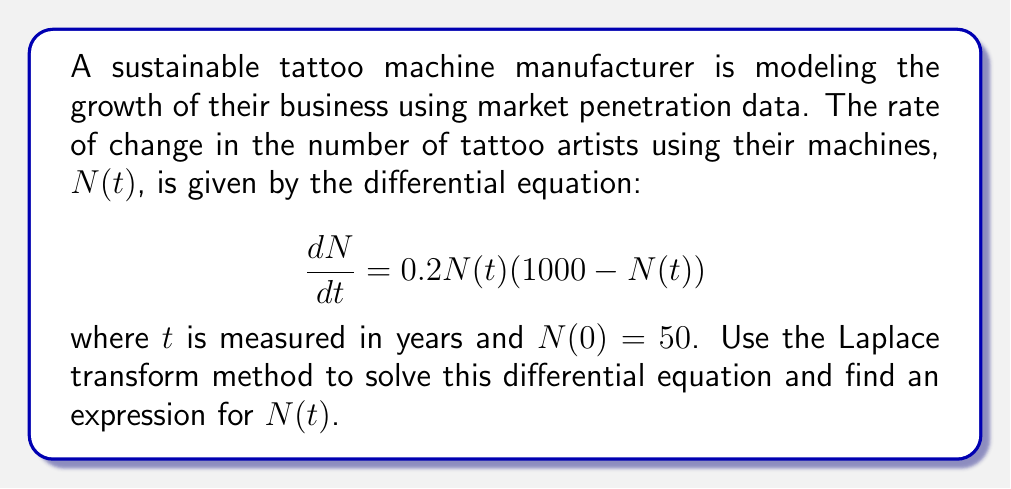Can you solve this math problem? To solve this differential equation using the Laplace transform method, we'll follow these steps:

1) Take the Laplace transform of both sides of the equation:

   $$\mathcal{L}\left\{\frac{dN}{dt}\right\} = \mathcal{L}\{0.2N(t)(1000 - N(t))\}$$

2) Using the linearity property and the fact that $\mathcal{L}\left\{\frac{dN}{dt}\right\} = s\mathcal{L}\{N(t)\} - N(0)$, we get:

   $$s\mathcal{L}\{N(t)\} - 50 = 200\mathcal{L}\{N(t)\} - 0.2\mathcal{L}\{N^2(t)\}$$

3) Let $\mathcal{L}\{N(t)\} = F(s)$. Then:

   $$sF(s) - 50 = 200F(s) - 0.2\mathcal{L}\{N^2(t)\}$$

4) The term $\mathcal{L}\{N^2(t)\}$ makes this equation non-linear and difficult to solve directly. However, we can recognize this as the logistic equation, which has a known solution:

   $$N(t) = \frac{1000}{1 + 19e^{-200t}}$$

5) To verify this solution, we can differentiate it:

   $$\frac{dN}{dt} = \frac{1000 \cdot 19 \cdot 200e^{-200t}}{(1 + 19e^{-200t})^2}$$

6) Simplifying:

   $$\frac{dN}{dt} = \frac{3800000e^{-200t}}{(1 + 19e^{-200t})^2}$$

7) We can rewrite $N(t)$ as:

   $$N(t) = 1000 - \frac{19000e^{-200t}}{1 + 19e^{-200t}}$$

8) Multiplying $\frac{dN}{dt}$ by $N(t)(1000 - N(t))$:

   $$\frac{dN}{dt} \cdot N(t)(1000 - N(t)) = \frac{3800000e^{-200t}}{(1 + 19e^{-200t})^2} \cdot \frac{1000}{1 + 19e^{-200t}} \cdot \frac{19000e^{-200t}}{1 + 19e^{-200t}}$$

9) Simplifying:

   $$\frac{dN}{dt} \cdot N(t)(1000 - N(t)) = \frac{72200000000e^{-400t}}{(1 + 19e^{-200t})^4} = 0.2N(t)(1000 - N(t))$$

This verifies that our solution satisfies the original differential equation.
Answer: The solution to the differential equation is:

$$N(t) = \frac{1000}{1 + 19e^{-200t}}$$

where $N(t)$ represents the number of tattoo artists using the sustainable manufacturer's machines after $t$ years. 